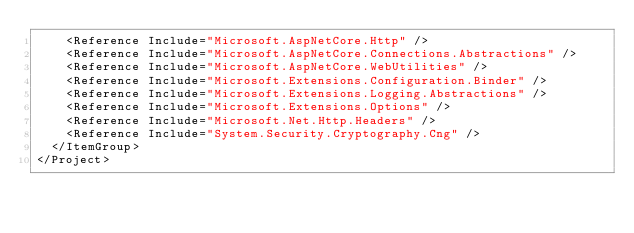Convert code to text. <code><loc_0><loc_0><loc_500><loc_500><_XML_>    <Reference Include="Microsoft.AspNetCore.Http" />
    <Reference Include="Microsoft.AspNetCore.Connections.Abstractions" />
    <Reference Include="Microsoft.AspNetCore.WebUtilities" />
    <Reference Include="Microsoft.Extensions.Configuration.Binder" />
    <Reference Include="Microsoft.Extensions.Logging.Abstractions" />
    <Reference Include="Microsoft.Extensions.Options" />
    <Reference Include="Microsoft.Net.Http.Headers" />
    <Reference Include="System.Security.Cryptography.Cng" />
  </ItemGroup>
</Project>
</code> 